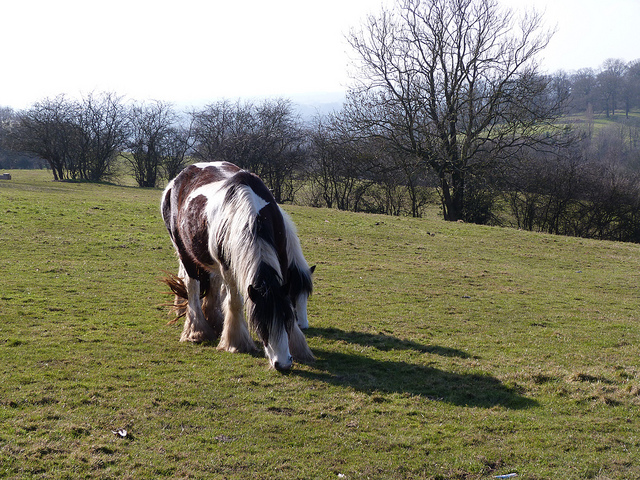Does the environment suggest a particular season? Describe. The environment suggests it might be late winter or early spring. The trees are bare, indicating that it’s not yet the growing season, but the grass is green and lush, suggesting that warmer weather is just beginning to arrive. If this picture were taken at twilight, how would it change the atmosphere? At twilight, the atmosphere would become more serene and mystical. The sky would be painted with hues of orange and purple, and the horse’s coat might glow softly under the setting sun. Shadows would lengthen, adding a dreamlike quality to the natural setting. 